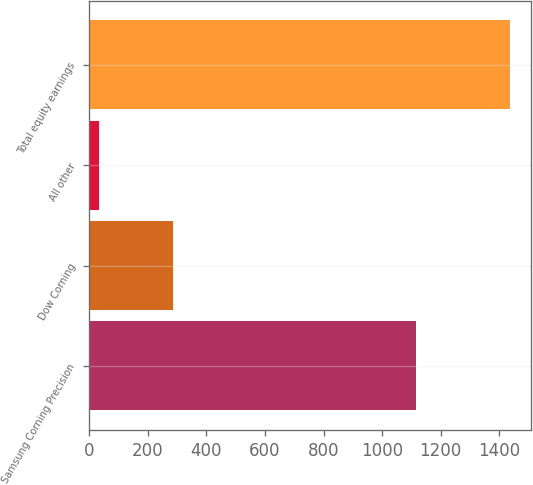<chart> <loc_0><loc_0><loc_500><loc_500><bar_chart><fcel>Samsung Corning Precision<fcel>Dow Corning<fcel>All other<fcel>Total equity earnings<nl><fcel>1115<fcel>287<fcel>33<fcel>1435<nl></chart> 